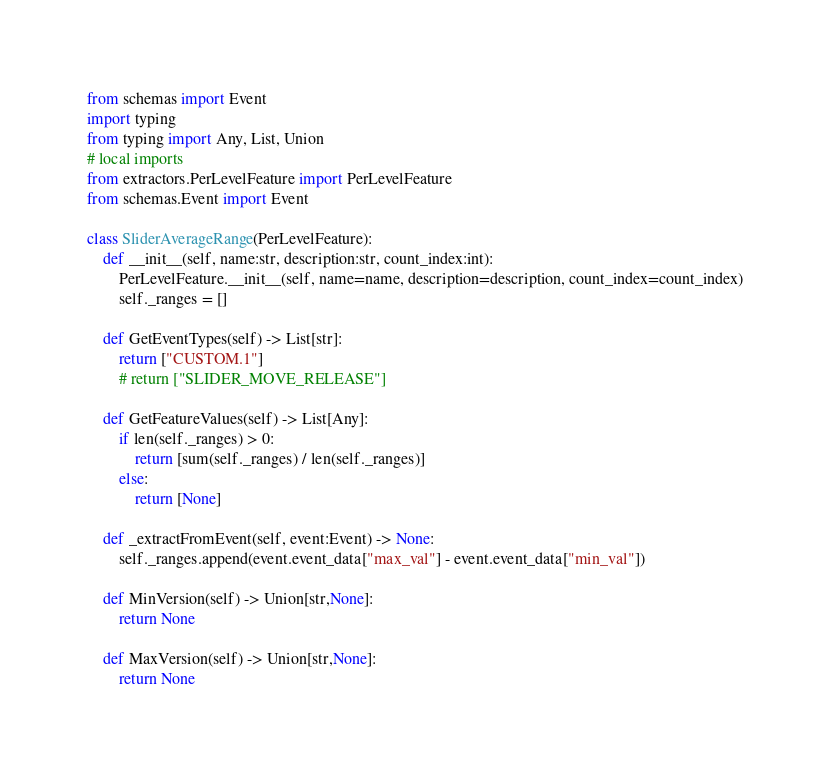<code> <loc_0><loc_0><loc_500><loc_500><_Python_>from schemas import Event
import typing
from typing import Any, List, Union
# local imports
from extractors.PerLevelFeature import PerLevelFeature
from schemas.Event import Event

class SliderAverageRange(PerLevelFeature):
    def __init__(self, name:str, description:str, count_index:int):
        PerLevelFeature.__init__(self, name=name, description=description, count_index=count_index)
        self._ranges = []

    def GetEventTypes(self) -> List[str]:
        return ["CUSTOM.1"]
        # return ["SLIDER_MOVE_RELEASE"]

    def GetFeatureValues(self) -> List[Any]:
        if len(self._ranges) > 0:
            return [sum(self._ranges) / len(self._ranges)]
        else:
            return [None]

    def _extractFromEvent(self, event:Event) -> None:
        self._ranges.append(event.event_data["max_val"] - event.event_data["min_val"])

    def MinVersion(self) -> Union[str,None]:
        return None

    def MaxVersion(self) -> Union[str,None]:
        return None
</code> 